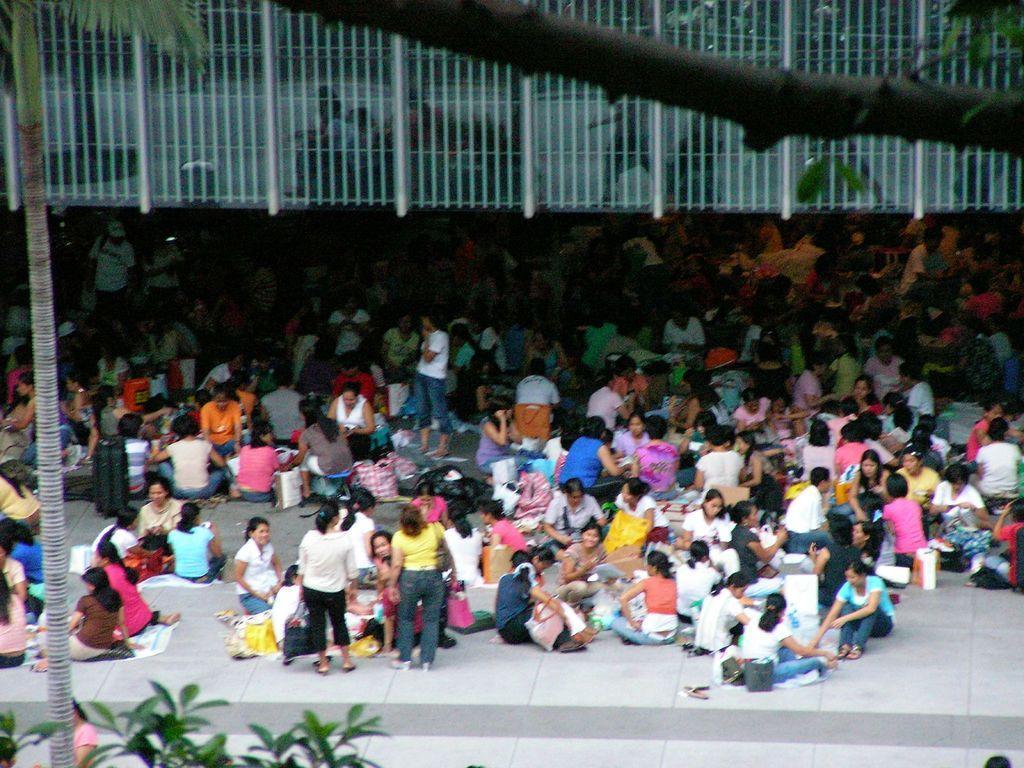Could you give a brief overview of what you see in this image? In this picture there are people those who are sitting in groups in the center of the image, some are eating and some are playing in groups, there are bags around them and there are trees on the left and at the top side of the image, there is a glass building at the top side of the image. 